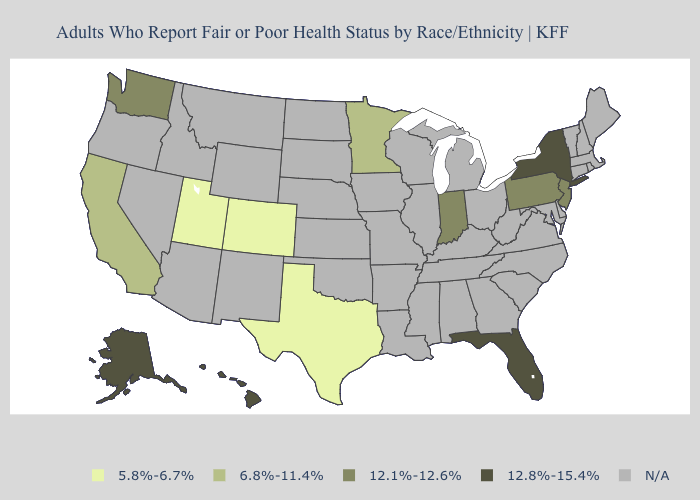Which states have the highest value in the USA?
Concise answer only. Alaska, Florida, Hawaii, New York. What is the highest value in the MidWest ?
Give a very brief answer. 12.1%-12.6%. Name the states that have a value in the range N/A?
Keep it brief. Alabama, Arizona, Arkansas, Connecticut, Delaware, Georgia, Idaho, Illinois, Iowa, Kansas, Kentucky, Louisiana, Maine, Maryland, Massachusetts, Michigan, Mississippi, Missouri, Montana, Nebraska, Nevada, New Hampshire, New Mexico, North Carolina, North Dakota, Ohio, Oklahoma, Oregon, Rhode Island, South Carolina, South Dakota, Tennessee, Vermont, Virginia, West Virginia, Wisconsin, Wyoming. Name the states that have a value in the range N/A?
Short answer required. Alabama, Arizona, Arkansas, Connecticut, Delaware, Georgia, Idaho, Illinois, Iowa, Kansas, Kentucky, Louisiana, Maine, Maryland, Massachusetts, Michigan, Mississippi, Missouri, Montana, Nebraska, Nevada, New Hampshire, New Mexico, North Carolina, North Dakota, Ohio, Oklahoma, Oregon, Rhode Island, South Carolina, South Dakota, Tennessee, Vermont, Virginia, West Virginia, Wisconsin, Wyoming. Which states have the lowest value in the Northeast?
Keep it brief. New Jersey, Pennsylvania. Name the states that have a value in the range N/A?
Concise answer only. Alabama, Arizona, Arkansas, Connecticut, Delaware, Georgia, Idaho, Illinois, Iowa, Kansas, Kentucky, Louisiana, Maine, Maryland, Massachusetts, Michigan, Mississippi, Missouri, Montana, Nebraska, Nevada, New Hampshire, New Mexico, North Carolina, North Dakota, Ohio, Oklahoma, Oregon, Rhode Island, South Carolina, South Dakota, Tennessee, Vermont, Virginia, West Virginia, Wisconsin, Wyoming. Name the states that have a value in the range 12.1%-12.6%?
Answer briefly. Indiana, New Jersey, Pennsylvania, Washington. What is the value of Pennsylvania?
Concise answer only. 12.1%-12.6%. Is the legend a continuous bar?
Short answer required. No. Name the states that have a value in the range 12.1%-12.6%?
Quick response, please. Indiana, New Jersey, Pennsylvania, Washington. Is the legend a continuous bar?
Concise answer only. No. What is the value of Hawaii?
Quick response, please. 12.8%-15.4%. What is the value of Mississippi?
Give a very brief answer. N/A. What is the value of Ohio?
Answer briefly. N/A. Which states have the lowest value in the West?
Give a very brief answer. Colorado, Utah. 